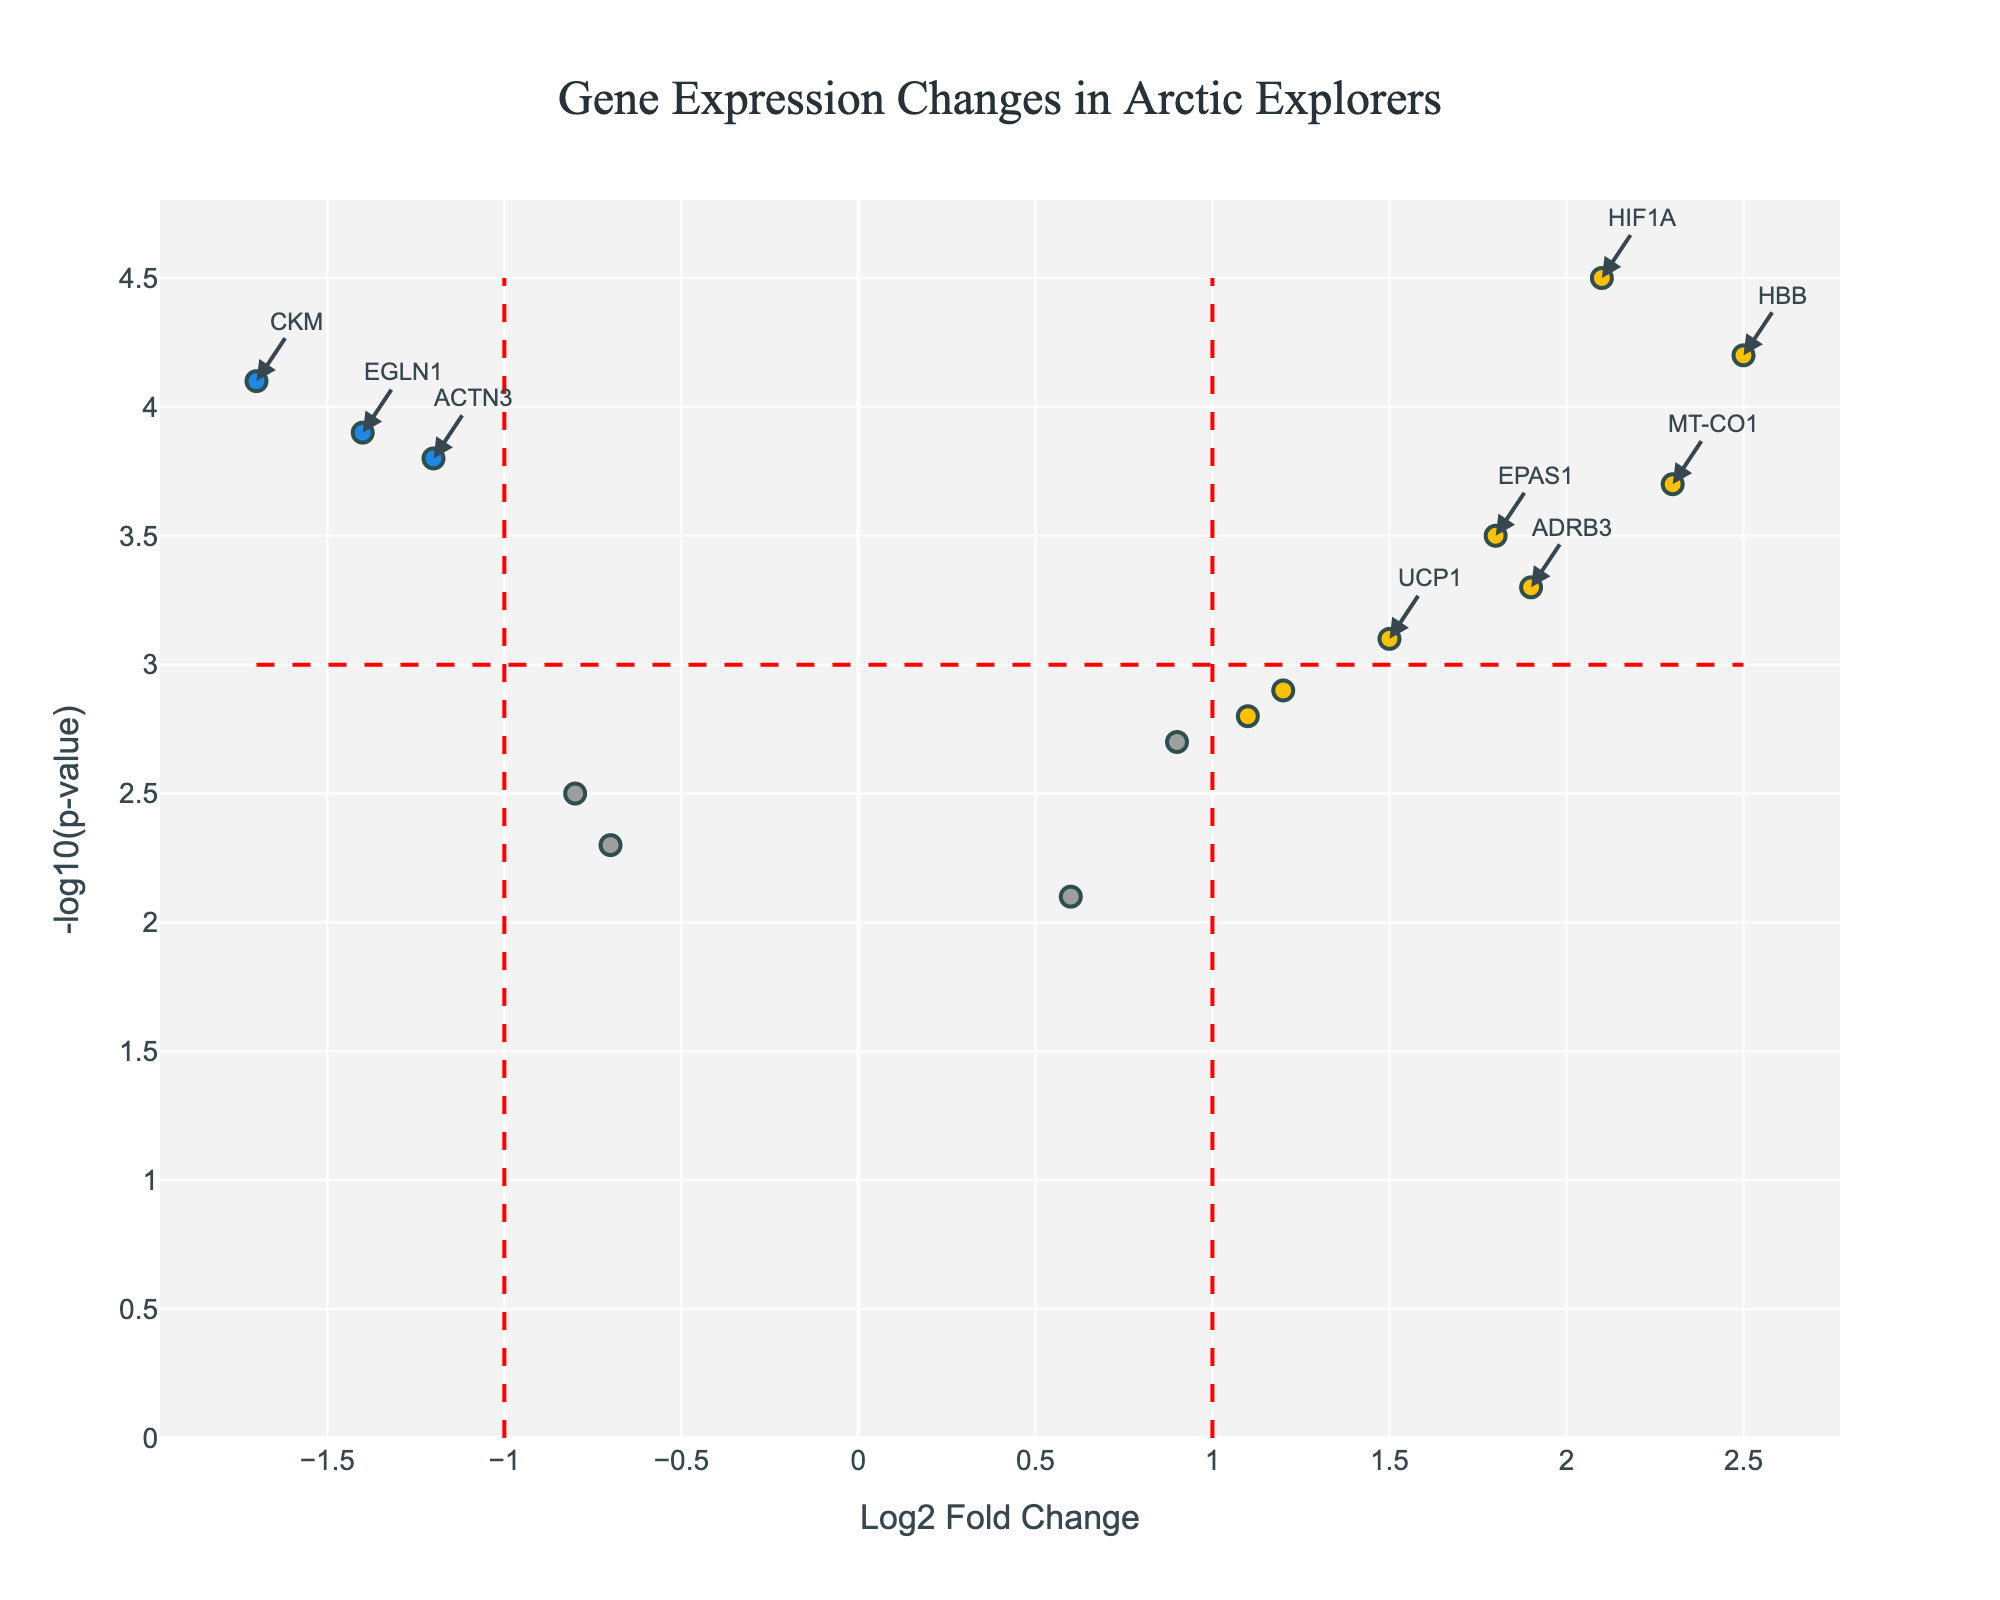How many genes are shown in the plot? Count the number of data points (markers) in the plot. Each marker represents a gene. There are 15 genes listed in the data table, corresponding to 15 data points in the plot.
Answer: 15 What does the title of the plot tell us? The title provides a brief description of what the plot represents. It tells us that the plot is comparing gene expression changes in Arctic explorers.
Answer: Gene Expression Changes in Arctic Explorers Which gene has the highest negative-log10 p-value? Look for the highest point on the y-axis. The gene corresponding to this point is HIF1A with a -log10 p-value of 4.5.
Answer: HIF1A How many genes have a log2 fold change greater than or equal to 1? Count the number of data points to the right of the vertical threshold line at log2 fold change of 1. There are 6 such genes (HBB, EPAS1, UCP1, HIF1A, MT-CO1, ADRB3).
Answer: 6 Which gene shows the most significant downregulation? Look for the gene with the lowest log2 fold change (most negative value) and a p-value above the threshold (higher -log10 p-value). The gene CKM shows downregulation with a log2 fold change of -1.7.
Answer: CKM Compare the genes HBB and NOS3 based on their log2 fold change and p-value. Which one shows a higher expression change and which one has a more significant p-value? HBB has a log2 fold change of 2.5 and -log10 p-value of 4.2; NOS3 has a log2 fold change of 0.6 and -log10 p-value of 2.1. HBB shows a higher expression change and a more significant p-value.
Answer: HBB for both Are there any genes with a log2 fold change between -1 and 1 and a significant p-value? Look for data points between the vertical threshold lines at -1 and 1 log2 fold change and above the horizontal threshold line at -log10 p-value of 3. There are no such genes in this plot.
Answer: No What is the log2 fold change and -log10 p-value for the gene LEP? Refer to the hover text data or look at the data point for LEP. LEP has a log2 fold change of 1.1 and a -log10 p-value of 2.8.
Answer: Log2 fold change: 1.1, -log10 p-value: 2.8 How many genes are significantly downregulated? Count the points to the left of -1 log2 fold change and above the -log10 p-value threshold of 3. There are 3 such genes (ACTN3, EGLN1, CKM).
Answer: 3 List the genes that are significantly upregulated. Identify the points to the right of the vertical line at 1 log2 fold change and above the horizontal line at -log10 p-value of 3. The genes are HBB, EPAS1, HIF1A, MT-CO1, ADRB3.
Answer: HBB, EPAS1, HIF1A, MT-CO1, ADRB3 